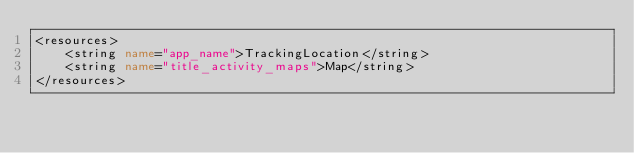<code> <loc_0><loc_0><loc_500><loc_500><_XML_><resources>
    <string name="app_name">TrackingLocation</string>
    <string name="title_activity_maps">Map</string>
</resources>
</code> 